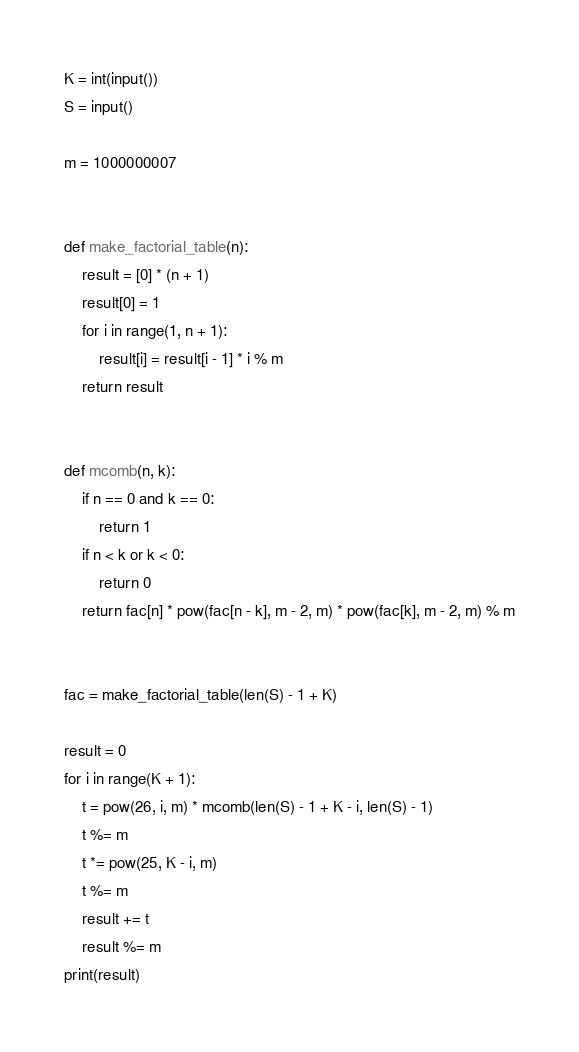<code> <loc_0><loc_0><loc_500><loc_500><_Python_>K = int(input())
S = input()

m = 1000000007


def make_factorial_table(n):
    result = [0] * (n + 1)
    result[0] = 1
    for i in range(1, n + 1):
        result[i] = result[i - 1] * i % m
    return result


def mcomb(n, k):
    if n == 0 and k == 0:
        return 1
    if n < k or k < 0:
        return 0
    return fac[n] * pow(fac[n - k], m - 2, m) * pow(fac[k], m - 2, m) % m


fac = make_factorial_table(len(S) - 1 + K)

result = 0
for i in range(K + 1):
    t = pow(26, i, m) * mcomb(len(S) - 1 + K - i, len(S) - 1)
    t %= m
    t *= pow(25, K - i, m)
    t %= m
    result += t
    result %= m
print(result)
</code> 